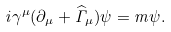<formula> <loc_0><loc_0><loc_500><loc_500>i \gamma ^ { \mu } ( \partial _ { \mu } + \widehat { \Gamma } _ { \mu } ) \psi = m \psi .</formula> 